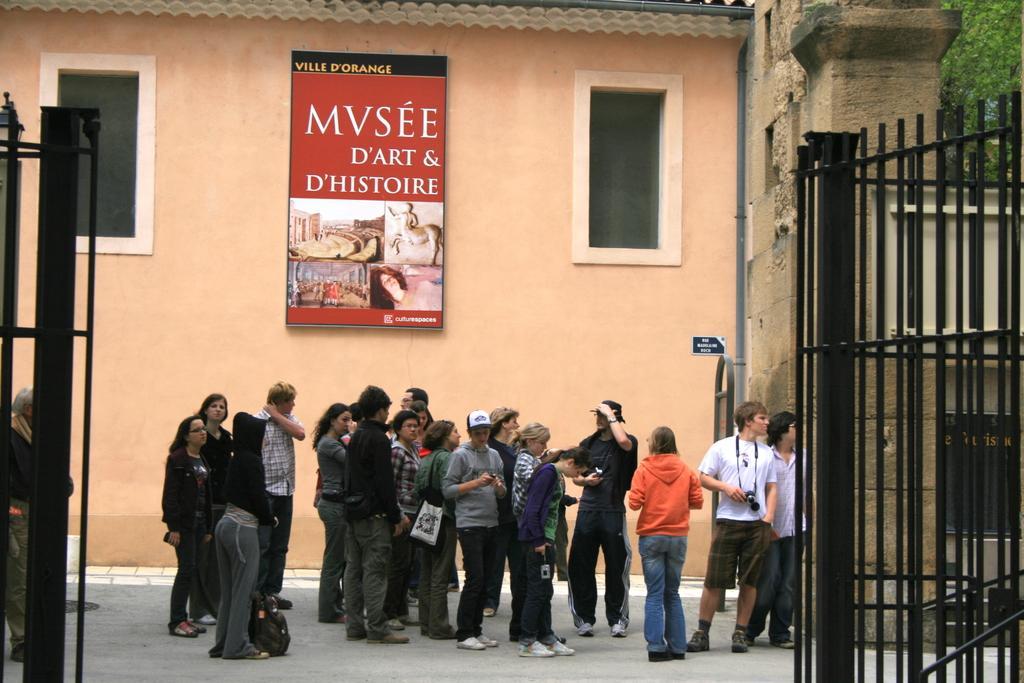Please provide a concise description of this image. In this picture we can see the wall, boards and the windows. We can see the group of people standing. On the right side of the picture we can see a black gate, tree, pillar. We can see the men and a man is wearing a white t-shirt. We can see he is carrying a camera. On the left side of the picture we can see a person standing. We can see a light and partial part of a gate. We can see a backpack on the floor. 